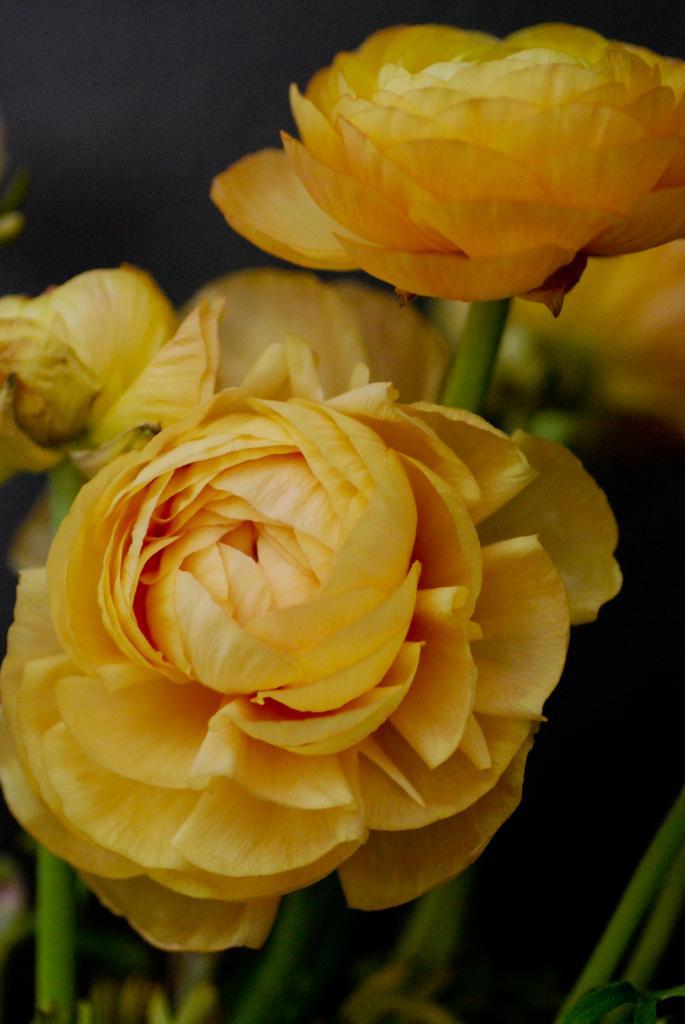How would you summarize this image in a sentence or two? In the foreground of this image, there are yellow flowers and the stems. 